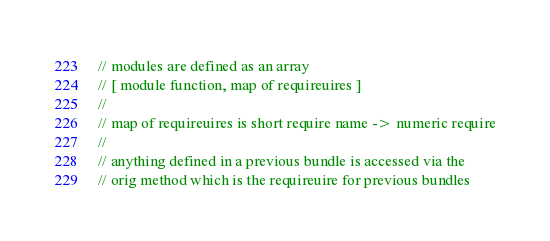Convert code to text. <code><loc_0><loc_0><loc_500><loc_500><_JavaScript_>// modules are defined as an array
// [ module function, map of requireuires ]
//
// map of requireuires is short require name -> numeric require
//
// anything defined in a previous bundle is accessed via the
// orig method which is the requireuire for previous bundles
</code> 